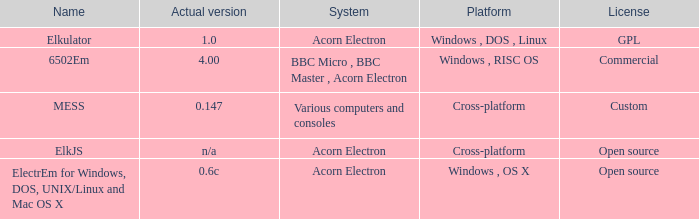What is the system called that is named ELKJS? Acorn Electron. 